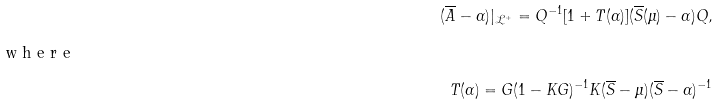<formula> <loc_0><loc_0><loc_500><loc_500>( \overline { A } - \alpha ) | _ { \mathcal { L } ^ { + } } = Q ^ { - 1 } [ 1 + T ( \alpha ) ] ( \overline { S } ( \mu ) - \alpha ) Q , \\ \intertext { w h e r e } T ( \alpha ) = G ( 1 - K G ) ^ { - 1 } K ( \overline { S } - \mu ) ( \overline { S } - \alpha ) ^ { - 1 }</formula> 